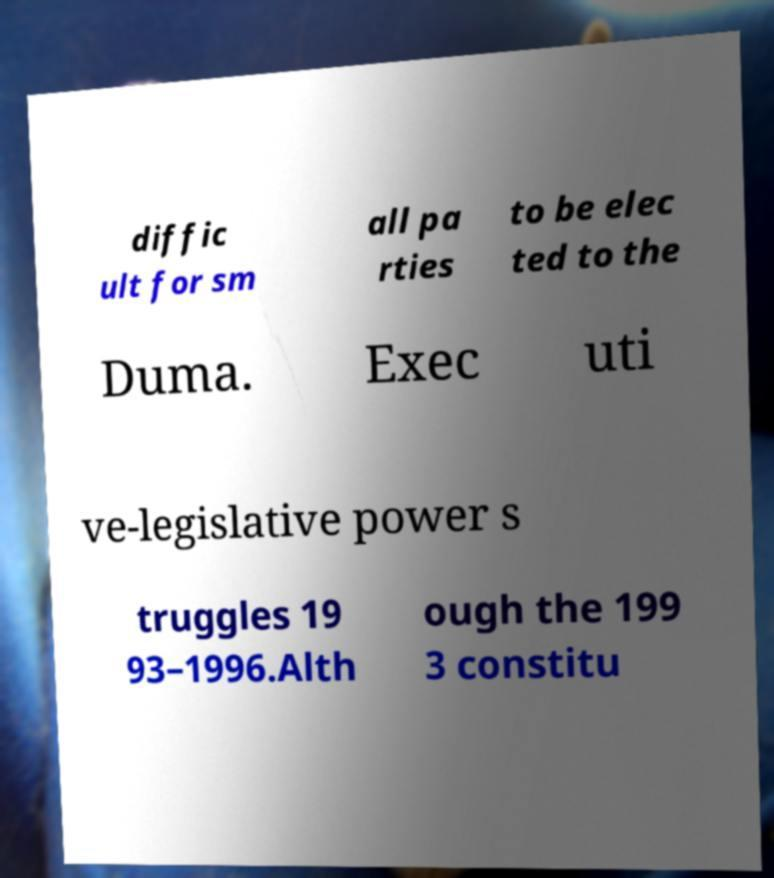Please read and relay the text visible in this image. What does it say? diffic ult for sm all pa rties to be elec ted to the Duma. Exec uti ve-legislative power s truggles 19 93–1996.Alth ough the 199 3 constitu 